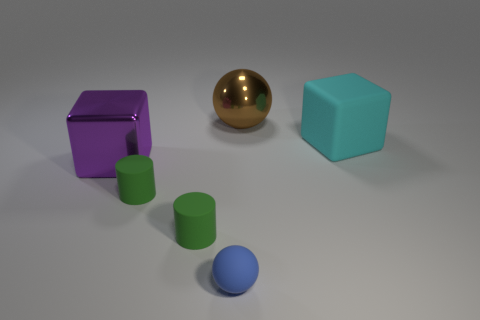Add 2 large purple cubes. How many objects exist? 8 Subtract 0 red cylinders. How many objects are left? 6 Subtract all blocks. How many objects are left? 4 Subtract all big matte cubes. Subtract all large cyan rubber things. How many objects are left? 4 Add 6 small matte things. How many small matte things are left? 9 Add 3 large matte cubes. How many large matte cubes exist? 4 